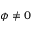<formula> <loc_0><loc_0><loc_500><loc_500>\phi \neq 0</formula> 